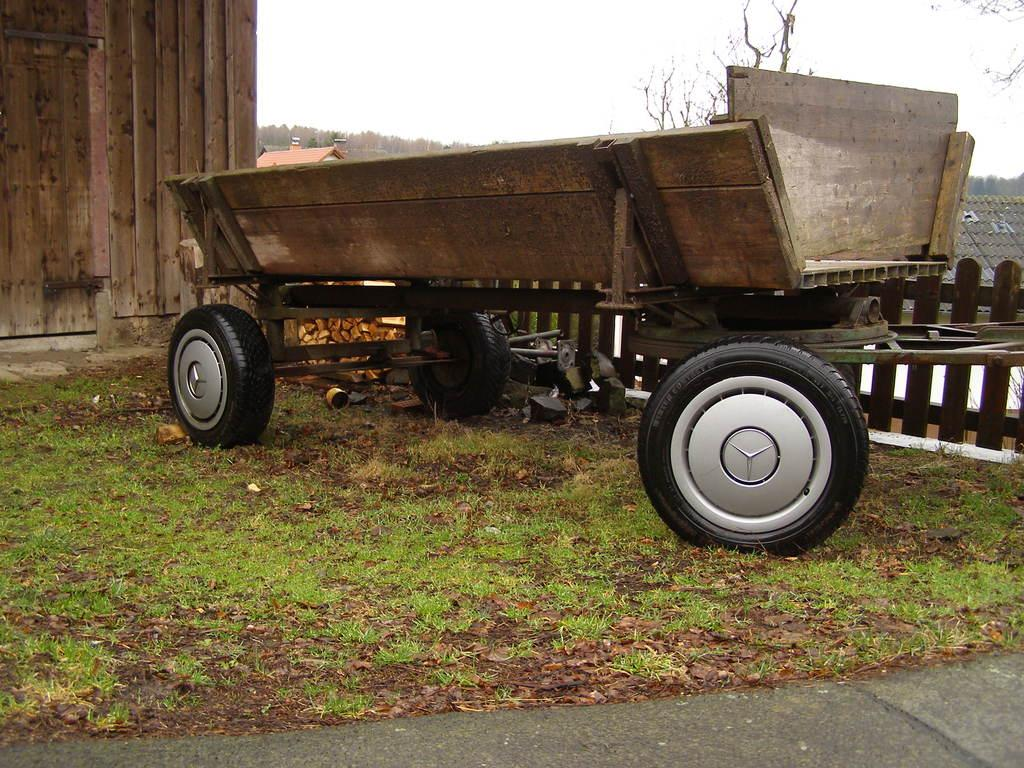What is located on the ground in the image? There is a vehicle on the ground in the image. What type of structure can be seen in the image? There is a wall with a door in the image. What can be seen in the background of the image? There is a shed, a fence, trees, and the sky visible in the background of the image. What color is the secretary's hair in the image? There is no secretary present in the image. What type of silver object can be seen in the image? There is no silver object present in the image. 